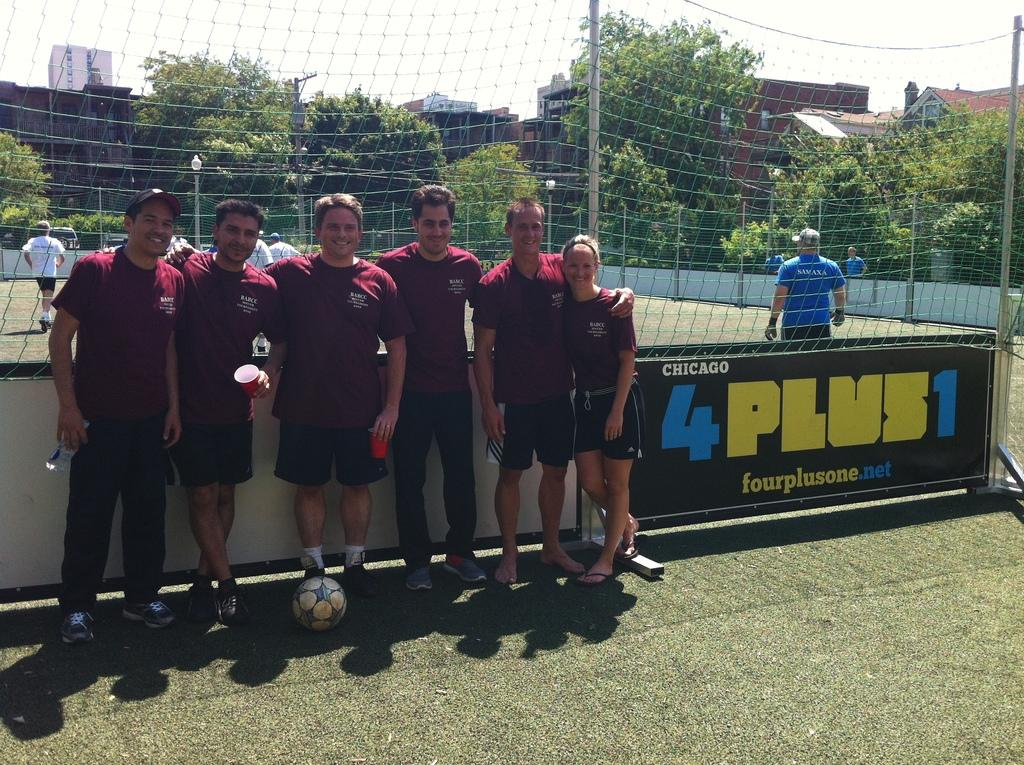What are the players in the image doing? The players are standing on the ground. What object is present in the image that is commonly used in sports? There is a ball in the image. What structure is present in the image that is used to separate teams or mark goals? There is a net in the image. What type of structures can be seen in the image that provide illumination? There are light poles in the image. What type of structure can be seen in the image that is used for electrical purposes? There is an electrical pole in the image. What type of man-made structures can be seen in the image? There are buildings in the image. What type of natural vegetation can be seen in the image? There are trees in the image. What part of the natural environment is visible in the image? The sky is visible in the image. How many pizzas are being delivered to the players in the image? There is no mention of pizzas or delivery in the image. What is the distance between the players and the buildings in the image? The image does not provide enough information to determine the exact distance between the players and the buildings. 